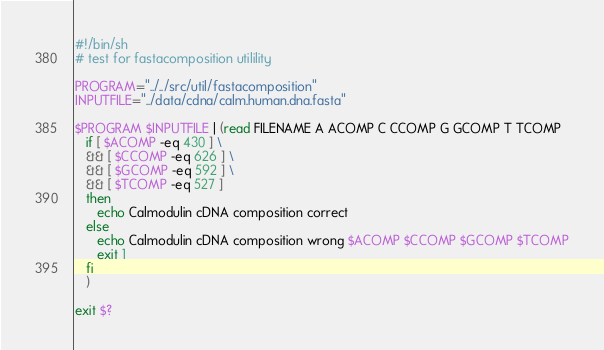<code> <loc_0><loc_0><loc_500><loc_500><_Bash_>#!/bin/sh
# test for fastacomposition utilility

PROGRAM="../../src/util/fastacomposition"
INPUTFILE="../data/cdna/calm.human.dna.fasta"

$PROGRAM $INPUTFILE | (read FILENAME A ACOMP C CCOMP G GCOMP T TCOMP
   if [ $ACOMP -eq 430 ] \
   && [ $CCOMP -eq 626 ] \
   && [ $GCOMP -eq 592 ] \
   && [ $TCOMP -eq 527 ]
   then
      echo Calmodulin cDNA composition correct
   else
      echo Calmodulin cDNA composition wrong $ACOMP $CCOMP $GCOMP $TCOMP
      exit 1
   fi
   )

exit $?

</code> 